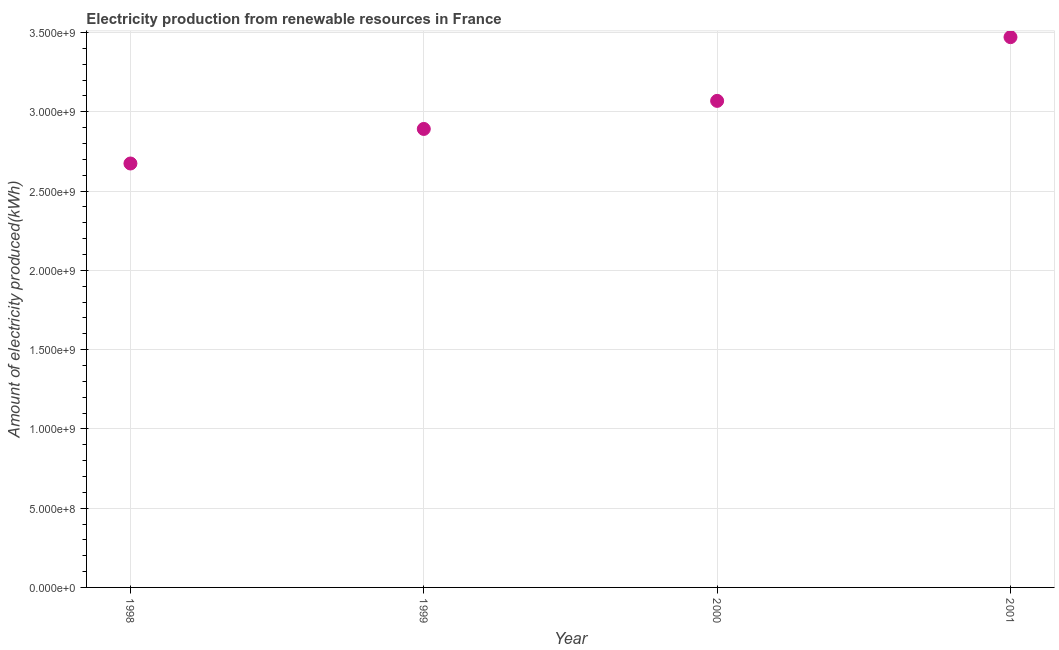What is the amount of electricity produced in 1999?
Give a very brief answer. 2.89e+09. Across all years, what is the maximum amount of electricity produced?
Make the answer very short. 3.47e+09. Across all years, what is the minimum amount of electricity produced?
Your response must be concise. 2.67e+09. In which year was the amount of electricity produced maximum?
Your response must be concise. 2001. What is the sum of the amount of electricity produced?
Your answer should be compact. 1.21e+1. What is the difference between the amount of electricity produced in 2000 and 2001?
Provide a short and direct response. -4.02e+08. What is the average amount of electricity produced per year?
Provide a succinct answer. 3.03e+09. What is the median amount of electricity produced?
Your response must be concise. 2.98e+09. In how many years, is the amount of electricity produced greater than 2700000000 kWh?
Ensure brevity in your answer.  3. What is the ratio of the amount of electricity produced in 1998 to that in 2000?
Give a very brief answer. 0.87. Is the amount of electricity produced in 2000 less than that in 2001?
Your answer should be compact. Yes. Is the difference between the amount of electricity produced in 1998 and 2001 greater than the difference between any two years?
Offer a terse response. Yes. What is the difference between the highest and the second highest amount of electricity produced?
Your answer should be compact. 4.02e+08. What is the difference between the highest and the lowest amount of electricity produced?
Offer a terse response. 7.97e+08. Does the graph contain any zero values?
Make the answer very short. No. What is the title of the graph?
Make the answer very short. Electricity production from renewable resources in France. What is the label or title of the Y-axis?
Your response must be concise. Amount of electricity produced(kWh). What is the Amount of electricity produced(kWh) in 1998?
Give a very brief answer. 2.67e+09. What is the Amount of electricity produced(kWh) in 1999?
Provide a short and direct response. 2.89e+09. What is the Amount of electricity produced(kWh) in 2000?
Your answer should be very brief. 3.07e+09. What is the Amount of electricity produced(kWh) in 2001?
Give a very brief answer. 3.47e+09. What is the difference between the Amount of electricity produced(kWh) in 1998 and 1999?
Ensure brevity in your answer.  -2.18e+08. What is the difference between the Amount of electricity produced(kWh) in 1998 and 2000?
Your answer should be very brief. -3.95e+08. What is the difference between the Amount of electricity produced(kWh) in 1998 and 2001?
Your response must be concise. -7.97e+08. What is the difference between the Amount of electricity produced(kWh) in 1999 and 2000?
Provide a succinct answer. -1.77e+08. What is the difference between the Amount of electricity produced(kWh) in 1999 and 2001?
Make the answer very short. -5.79e+08. What is the difference between the Amount of electricity produced(kWh) in 2000 and 2001?
Ensure brevity in your answer.  -4.02e+08. What is the ratio of the Amount of electricity produced(kWh) in 1998 to that in 1999?
Provide a short and direct response. 0.93. What is the ratio of the Amount of electricity produced(kWh) in 1998 to that in 2000?
Offer a very short reply. 0.87. What is the ratio of the Amount of electricity produced(kWh) in 1998 to that in 2001?
Your answer should be very brief. 0.77. What is the ratio of the Amount of electricity produced(kWh) in 1999 to that in 2000?
Provide a succinct answer. 0.94. What is the ratio of the Amount of electricity produced(kWh) in 1999 to that in 2001?
Your answer should be very brief. 0.83. What is the ratio of the Amount of electricity produced(kWh) in 2000 to that in 2001?
Offer a very short reply. 0.88. 